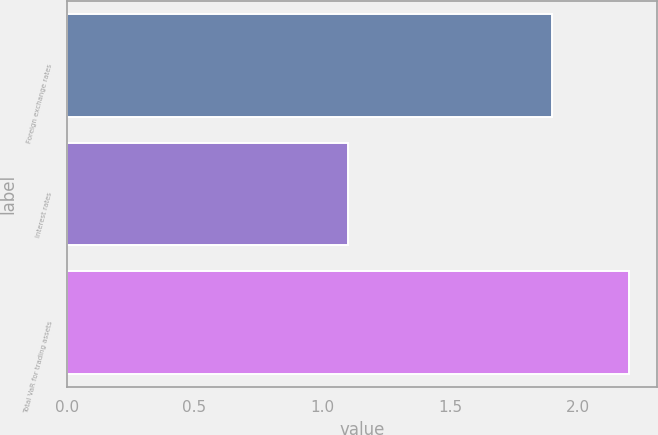<chart> <loc_0><loc_0><loc_500><loc_500><bar_chart><fcel>Foreign exchange rates<fcel>Interest rates<fcel>Total VaR for trading assets<nl><fcel>1.9<fcel>1.1<fcel>2.2<nl></chart> 